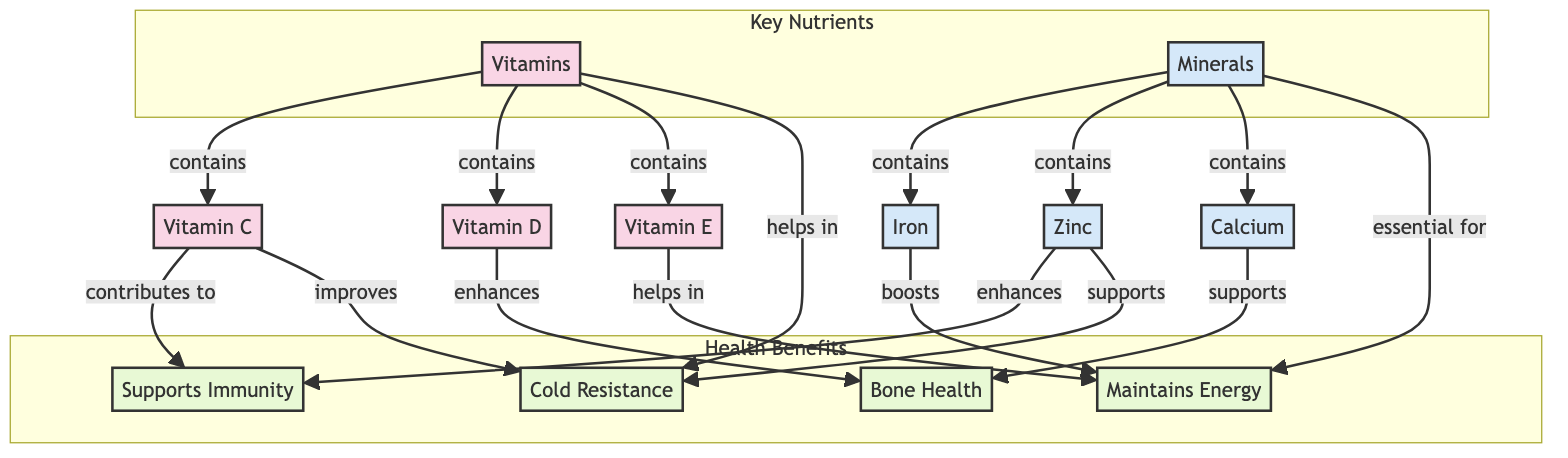What are the key vitamins mentioned in the diagram? The diagram lists three specific vitamins: Vitamin C, Vitamin D, and Vitamin E under the 'Vitamins' node.
Answer: Vitamin C, Vitamin D, Vitamin E Which minerals are identified in the diagram? The diagram specifies three minerals: Iron, Zinc, and Calcium found under the 'Minerals' node.
Answer: Iron, Zinc, Calcium How many health benefits are highlighted in the diagram? There are four health benefits depicted in the 'Health Benefits' section of the diagram: Supports Immunity, Bone Health, Maintains Energy, and Cold Resistance.
Answer: 4 Which vitamin contributes to energy maintenance? The diagram indicates that both Vitamin E and Iron contribute to 'Maintains Energy', linking them directly to this health benefit.
Answer: Vitamin E, Iron What is the relationship between Vitamin C and cold resistance? According to the diagram, Vitamin C is shown to improve cold resistance, establishing a direct link from Vitamin C to the benefit of cold resistance.
Answer: Improves How do Zinc and Calcium relate to bone health? The diagram shows Zinc enhances immunity support and Calcium supports bone health, indicating separate but direct relationships to health benefits.
Answer: Zinc enhances, Calcium supports Which category do vitamins belong to in the diagram? Vitamins are categorized under 'Key Nutrients' in the diagram, specifically listed alongside minerals.
Answer: Key Nutrients Is energy maintenance linked to both vitamins and minerals? Yes, the diagram shows that minerals are essential for energy maintenance and also lists Vitamin E and Iron as contributing to this benefit, highlighting the connection.
Answer: Yes 